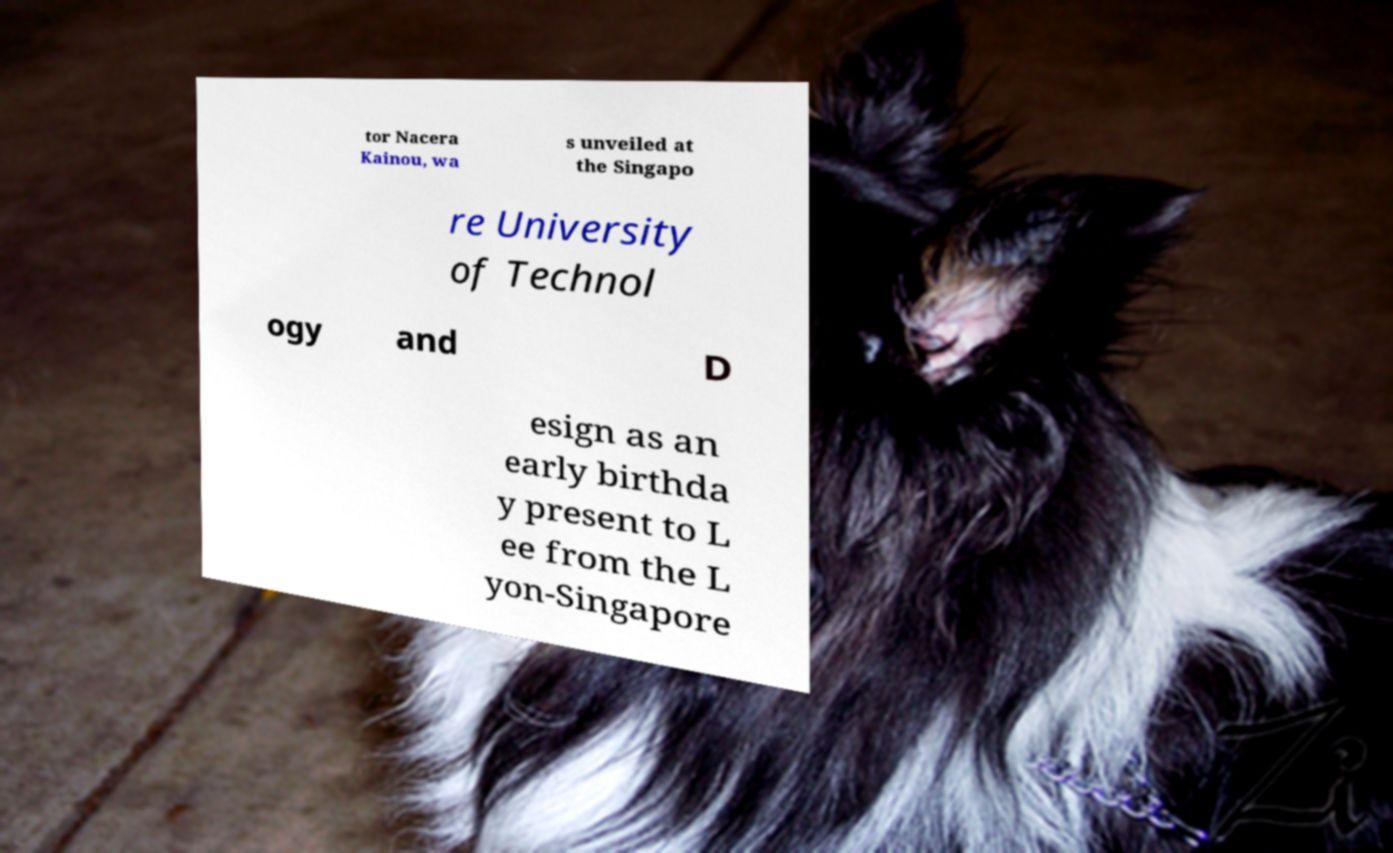What messages or text are displayed in this image? I need them in a readable, typed format. tor Nacera Kainou, wa s unveiled at the Singapo re University of Technol ogy and D esign as an early birthda y present to L ee from the L yon-Singapore 